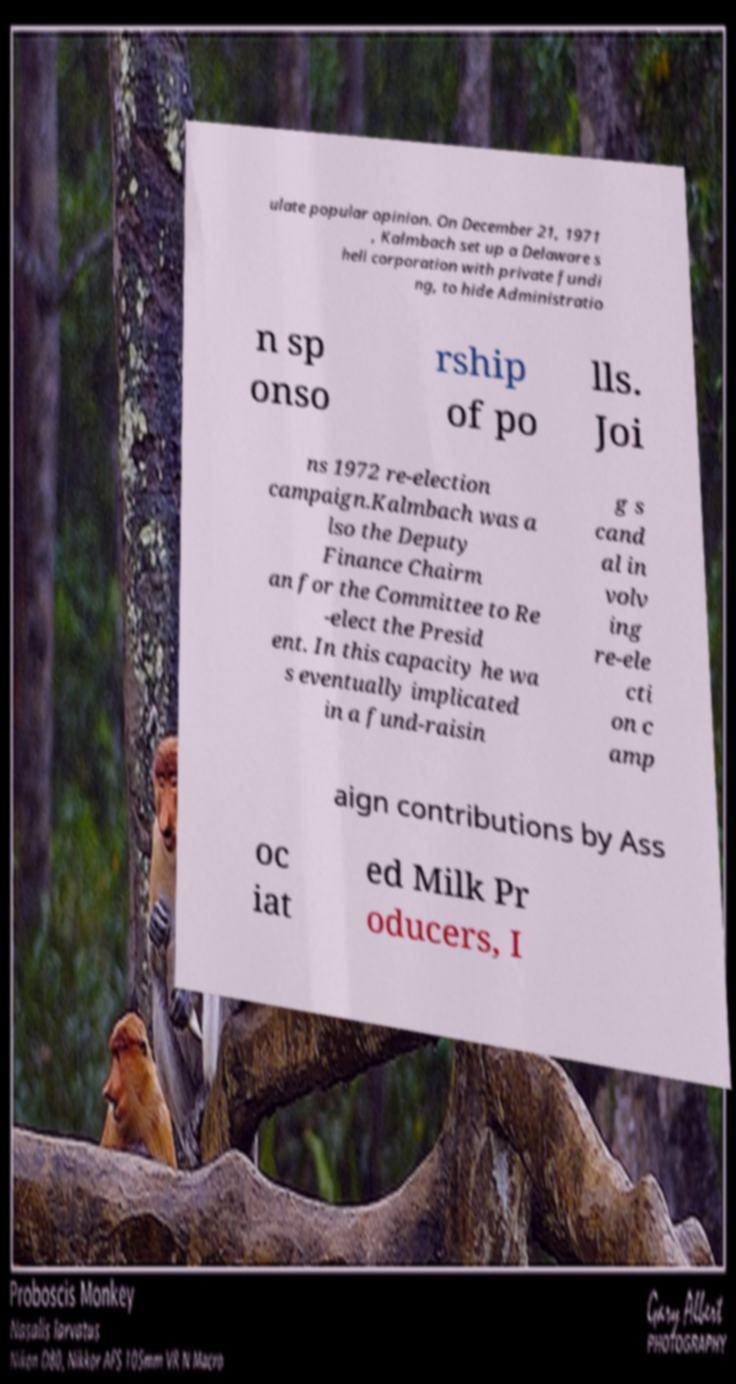Can you accurately transcribe the text from the provided image for me? ulate popular opinion. On December 21, 1971 , Kalmbach set up a Delaware s hell corporation with private fundi ng, to hide Administratio n sp onso rship of po lls. Joi ns 1972 re-election campaign.Kalmbach was a lso the Deputy Finance Chairm an for the Committee to Re -elect the Presid ent. In this capacity he wa s eventually implicated in a fund-raisin g s cand al in volv ing re-ele cti on c amp aign contributions by Ass oc iat ed Milk Pr oducers, I 